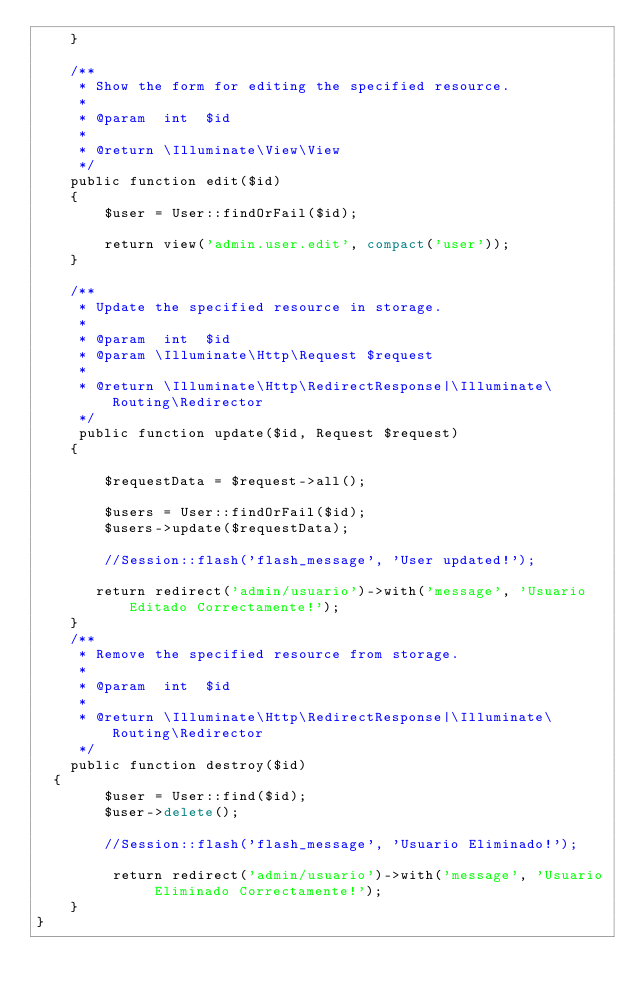Convert code to text. <code><loc_0><loc_0><loc_500><loc_500><_PHP_>    }

    /**
     * Show the form for editing the specified resource.
     *
     * @param  int  $id
     *
     * @return \Illuminate\View\View
     */
    public function edit($id)
    {
        $user = User::findOrFail($id);

        return view('admin.user.edit', compact('user'));
    }

    /**
     * Update the specified resource in storage.
     *
     * @param  int  $id
     * @param \Illuminate\Http\Request $request
     *
     * @return \Illuminate\Http\RedirectResponse|\Illuminate\Routing\Redirector
     */
     public function update($id, Request $request)
    {
        
        $requestData = $request->all();
        
        $users = User::findOrFail($id);
        $users->update($requestData);

        //Session::flash('flash_message', 'User updated!');

       return redirect('admin/usuario')->with('message', 'Usuario Editado Correctamente!');
    }
    /**
     * Remove the specified resource from storage.
     *
     * @param  int  $id
     *
     * @return \Illuminate\Http\RedirectResponse|\Illuminate\Routing\Redirector
     */
    public function destroy($id)
  {
        $user = User::find($id);
        $user->delete();

        //Session::flash('flash_message', 'Usuario Eliminado!');

         return redirect('admin/usuario')->with('message', 'Usuario Eliminado Correctamente!');
    }
}
</code> 